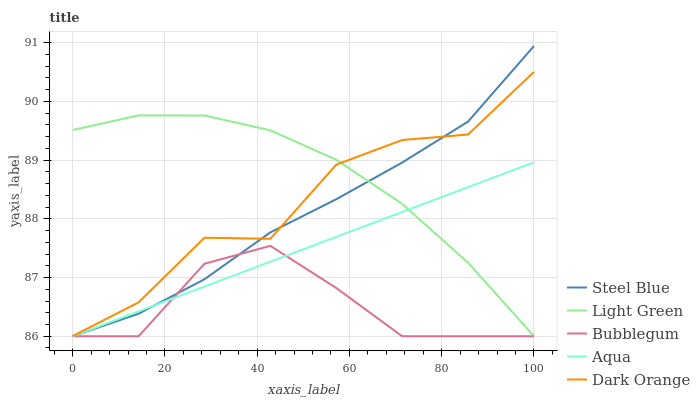Does Bubblegum have the minimum area under the curve?
Answer yes or no. Yes. Does Light Green have the maximum area under the curve?
Answer yes or no. Yes. Does Aqua have the minimum area under the curve?
Answer yes or no. No. Does Aqua have the maximum area under the curve?
Answer yes or no. No. Is Aqua the smoothest?
Answer yes or no. Yes. Is Dark Orange the roughest?
Answer yes or no. Yes. Is Bubblegum the smoothest?
Answer yes or no. No. Is Bubblegum the roughest?
Answer yes or no. No. Does Bubblegum have the lowest value?
Answer yes or no. Yes. Does Light Green have the lowest value?
Answer yes or no. No. Does Steel Blue have the highest value?
Answer yes or no. Yes. Does Aqua have the highest value?
Answer yes or no. No. Is Bubblegum less than Dark Orange?
Answer yes or no. Yes. Is Light Green greater than Bubblegum?
Answer yes or no. Yes. Does Dark Orange intersect Steel Blue?
Answer yes or no. Yes. Is Dark Orange less than Steel Blue?
Answer yes or no. No. Is Dark Orange greater than Steel Blue?
Answer yes or no. No. Does Bubblegum intersect Dark Orange?
Answer yes or no. No. 